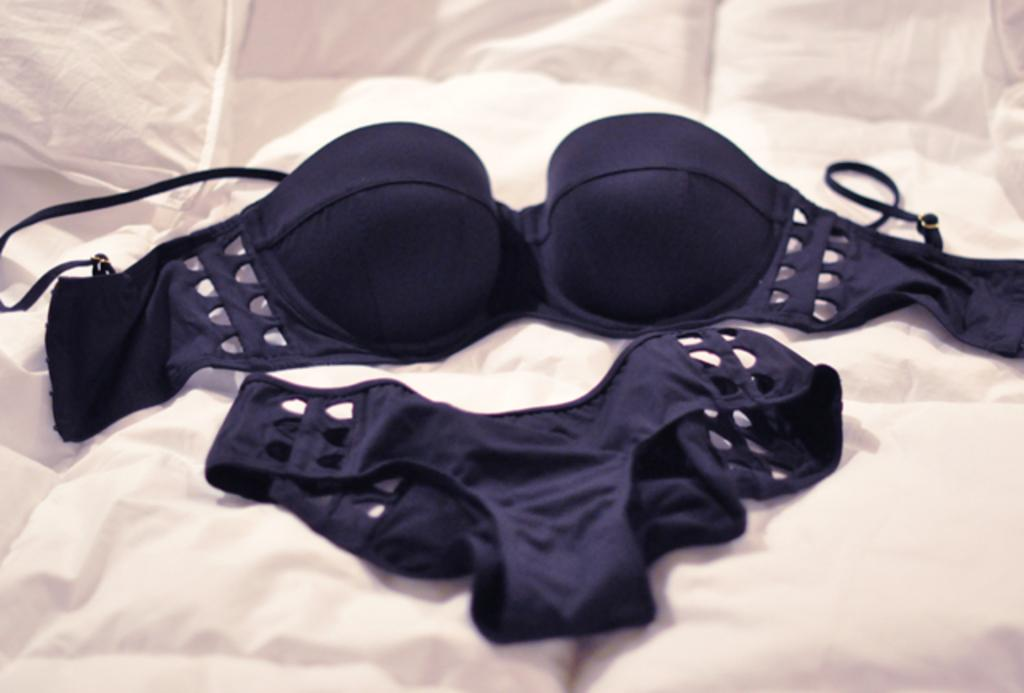What type of clothing items are in the image? There are undergarments in the image. Where are the undergarments placed? The undergarments are on a white cloth. What type of plants can be seen growing in the undergarments in the image? There are no plants visible in the image, as it features undergarments on a white cloth. 